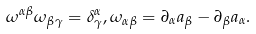<formula> <loc_0><loc_0><loc_500><loc_500>\omega ^ { \alpha \beta } \omega _ { \beta \gamma } = \delta ^ { \alpha } _ { \gamma } , \omega _ { \alpha \beta } = \partial _ { \alpha } a _ { \beta } - \partial _ { \beta } a _ { \alpha } .</formula> 